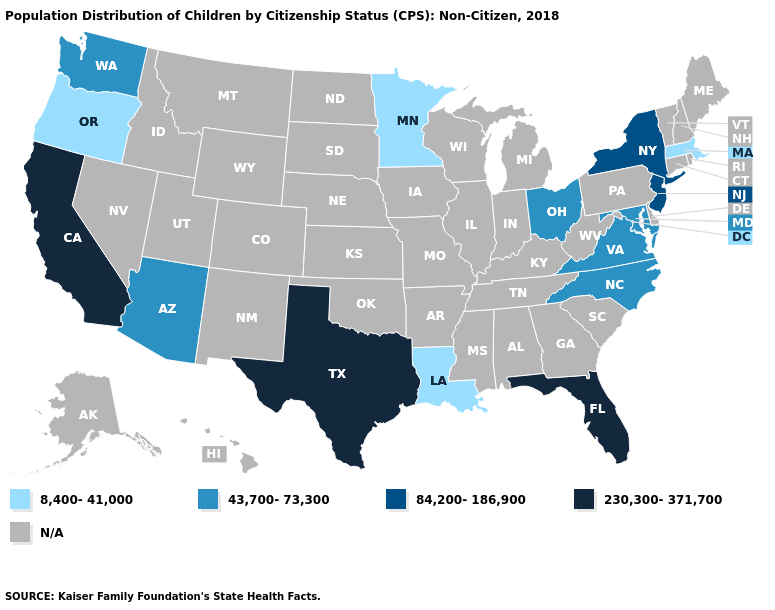Is the legend a continuous bar?
Be succinct. No. Name the states that have a value in the range 230,300-371,700?
Short answer required. California, Florida, Texas. Does the first symbol in the legend represent the smallest category?
Be succinct. Yes. Name the states that have a value in the range 8,400-41,000?
Short answer required. Louisiana, Massachusetts, Minnesota, Oregon. Does Louisiana have the highest value in the USA?
Concise answer only. No. Does the first symbol in the legend represent the smallest category?
Quick response, please. Yes. What is the highest value in the West ?
Keep it brief. 230,300-371,700. Which states have the lowest value in the MidWest?
Keep it brief. Minnesota. Does Florida have the highest value in the USA?
Keep it brief. Yes. What is the lowest value in the South?
Be succinct. 8,400-41,000. What is the lowest value in states that border Connecticut?
Give a very brief answer. 8,400-41,000. Name the states that have a value in the range 230,300-371,700?
Write a very short answer. California, Florida, Texas. 